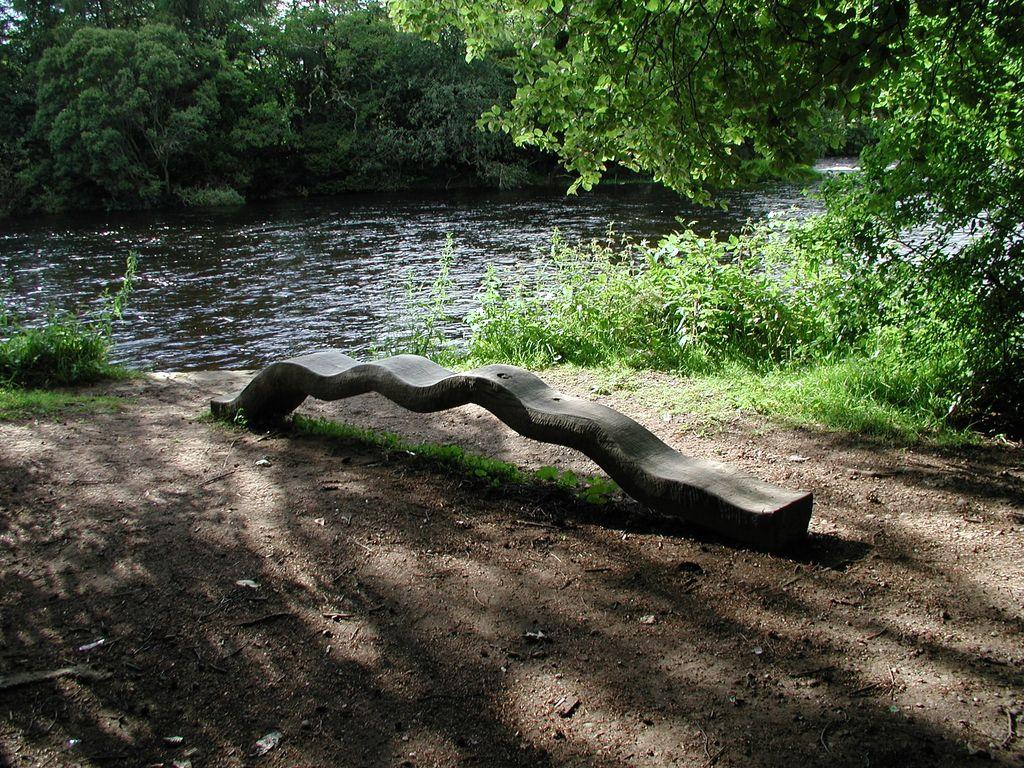What type of water feature can be seen in the image? There is a canal in the image. What type of vegetation is present in the image? Trees and plants are present in the image. Can you describe a seating area in the image? There is a bench in the middle of the image. How many chairs are placed around the table in the cave in the image? There is no table, chairs, or cave present in the image. 